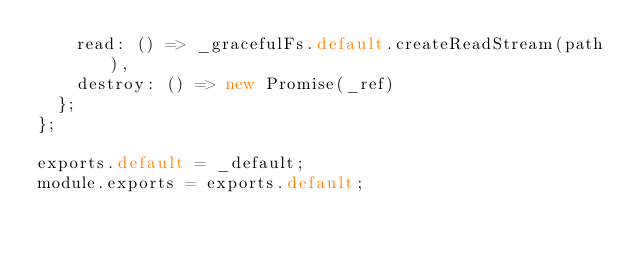<code> <loc_0><loc_0><loc_500><loc_500><_JavaScript_>    read: () => _gracefulFs.default.createReadStream(path),
    destroy: () => new Promise(_ref)
  };
};

exports.default = _default;
module.exports = exports.default;</code> 